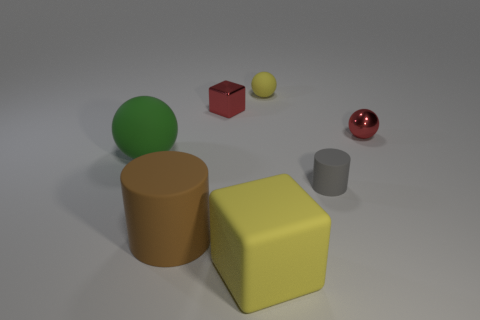Add 1 small cyan metal blocks. How many objects exist? 8 Subtract all blocks. How many objects are left? 5 Subtract 0 purple cubes. How many objects are left? 7 Subtract all large matte cylinders. Subtract all small shiny spheres. How many objects are left? 5 Add 1 brown objects. How many brown objects are left? 2 Add 6 yellow spheres. How many yellow spheres exist? 7 